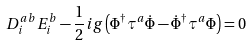<formula> <loc_0><loc_0><loc_500><loc_500>D _ { i } ^ { a b } E _ { i } ^ { b } - { \frac { 1 } { 2 } } i g \left ( \Phi ^ { \dagger } \tau ^ { a } \dot { \Phi } - \dot { \Phi } ^ { \dagger } \tau ^ { a } \Phi \right ) = 0</formula> 